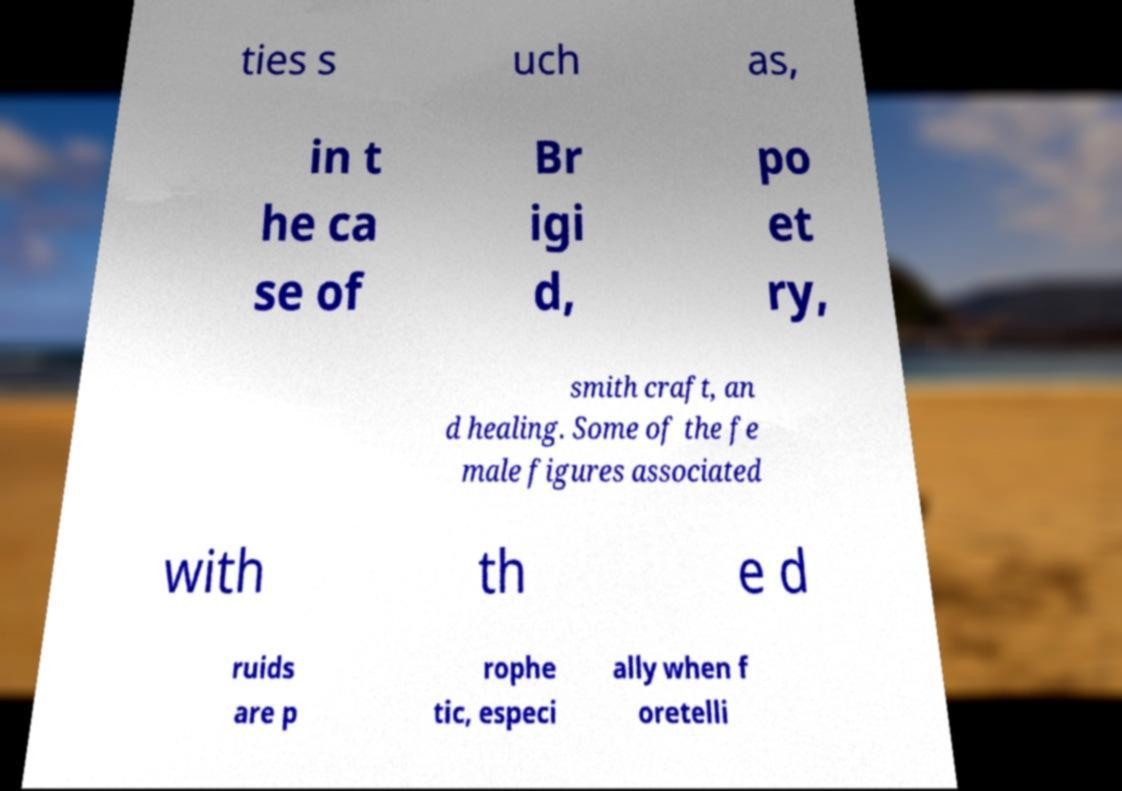Please read and relay the text visible in this image. What does it say? ties s uch as, in t he ca se of Br igi d, po et ry, smith craft, an d healing. Some of the fe male figures associated with th e d ruids are p rophe tic, especi ally when f oretelli 